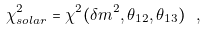Convert formula to latex. <formula><loc_0><loc_0><loc_500><loc_500>\chi ^ { 2 } _ { s o l a r } = \chi ^ { 2 } ( \delta m ^ { 2 } , \theta _ { 1 2 } , \theta _ { 1 3 } ) \ ,</formula> 